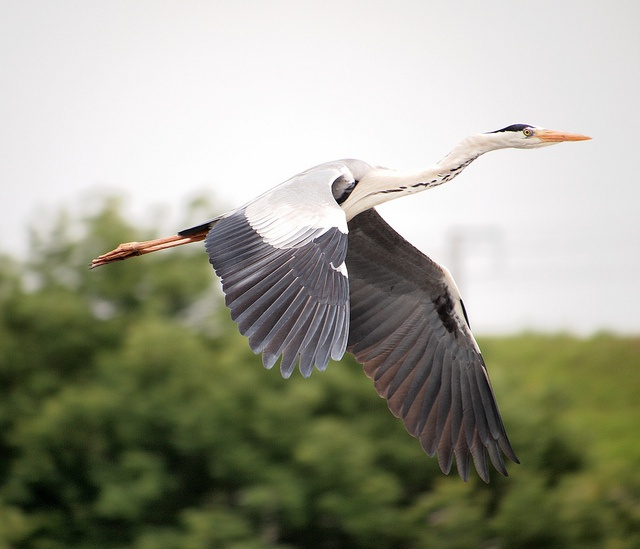Describe the objects in this image and their specific colors. I can see a bird in lightgray, gray, and black tones in this image. 